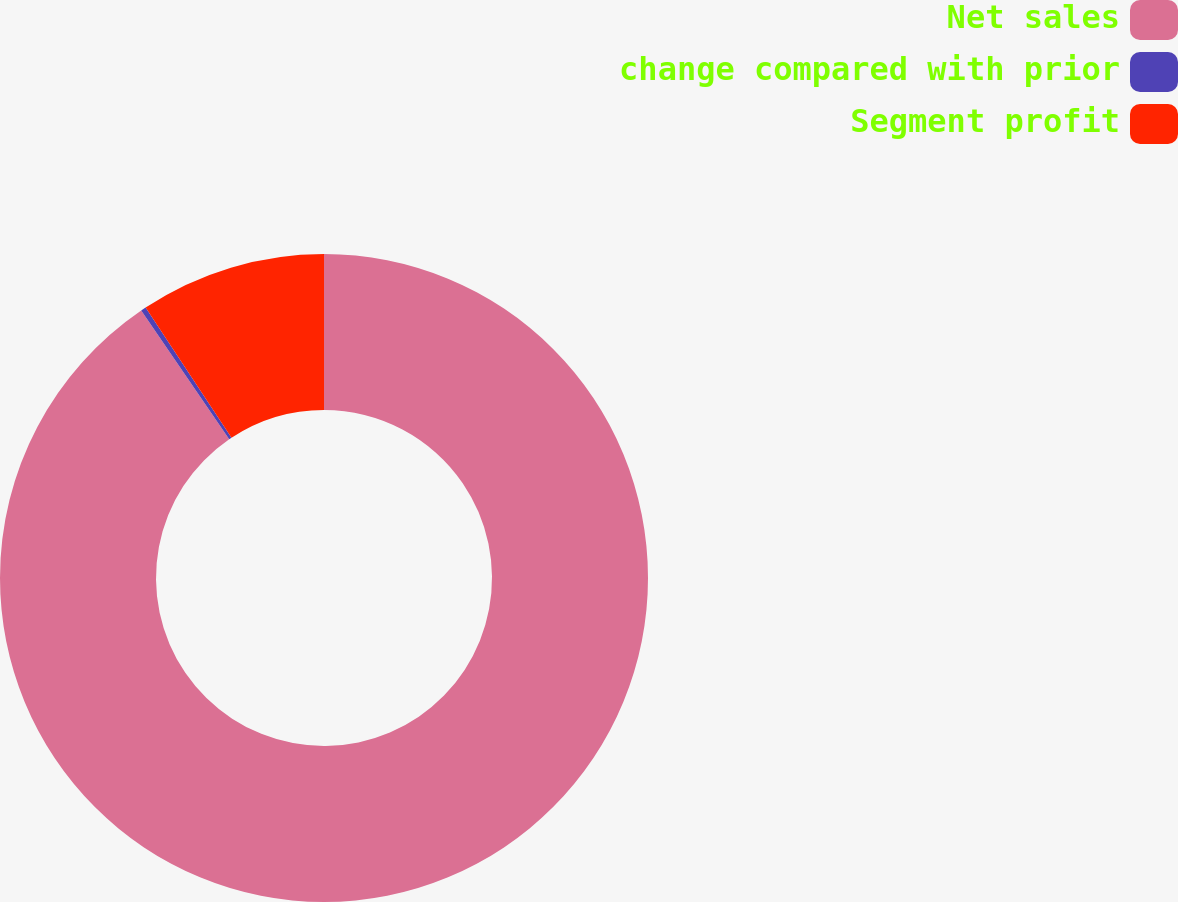<chart> <loc_0><loc_0><loc_500><loc_500><pie_chart><fcel>Net sales<fcel>change compared with prior<fcel>Segment profit<nl><fcel>90.46%<fcel>0.26%<fcel>9.28%<nl></chart> 